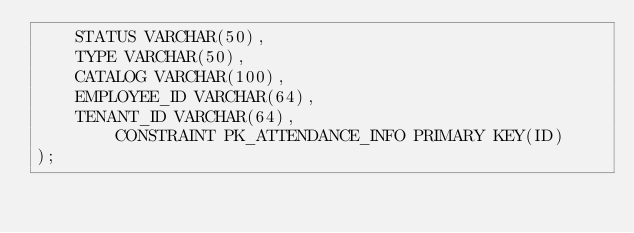<code> <loc_0><loc_0><loc_500><loc_500><_SQL_>	STATUS VARCHAR(50),
	TYPE VARCHAR(50),
	CATALOG VARCHAR(100),
	EMPLOYEE_ID VARCHAR(64),
	TENANT_ID VARCHAR(64),
        CONSTRAINT PK_ATTENDANCE_INFO PRIMARY KEY(ID)
);

</code> 